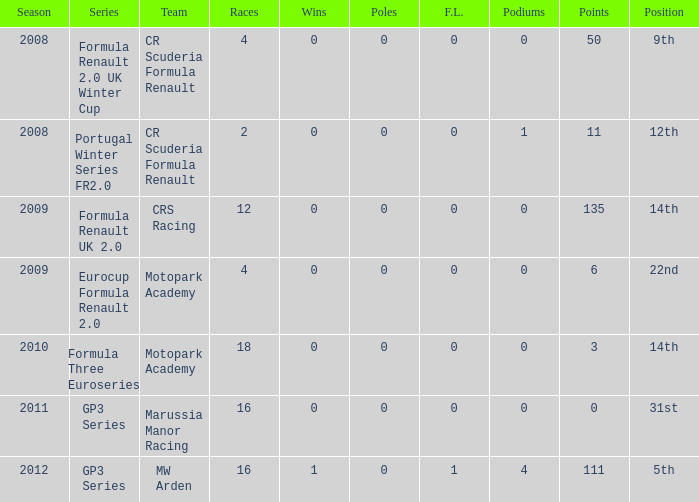What is the minimum number of podiums? 0.0. Can you parse all the data within this table? {'header': ['Season', 'Series', 'Team', 'Races', 'Wins', 'Poles', 'F.L.', 'Podiums', 'Points', 'Position'], 'rows': [['2008', 'Formula Renault 2.0 UK Winter Cup', 'CR Scuderia Formula Renault', '4', '0', '0', '0', '0', '50', '9th'], ['2008', 'Portugal Winter Series FR2.0', 'CR Scuderia Formula Renault', '2', '0', '0', '0', '1', '11', '12th'], ['2009', 'Formula Renault UK 2.0', 'CRS Racing', '12', '0', '0', '0', '0', '135', '14th'], ['2009', 'Eurocup Formula Renault 2.0', 'Motopark Academy', '4', '0', '0', '0', '0', '6', '22nd'], ['2010', 'Formula Three Euroseries', 'Motopark Academy', '18', '0', '0', '0', '0', '3', '14th'], ['2011', 'GP3 Series', 'Marussia Manor Racing', '16', '0', '0', '0', '0', '0', '31st'], ['2012', 'GP3 Series', 'MW Arden', '16', '1', '0', '1', '4', '111', '5th']]} 